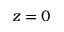Convert formula to latex. <formula><loc_0><loc_0><loc_500><loc_500>z = 0</formula> 